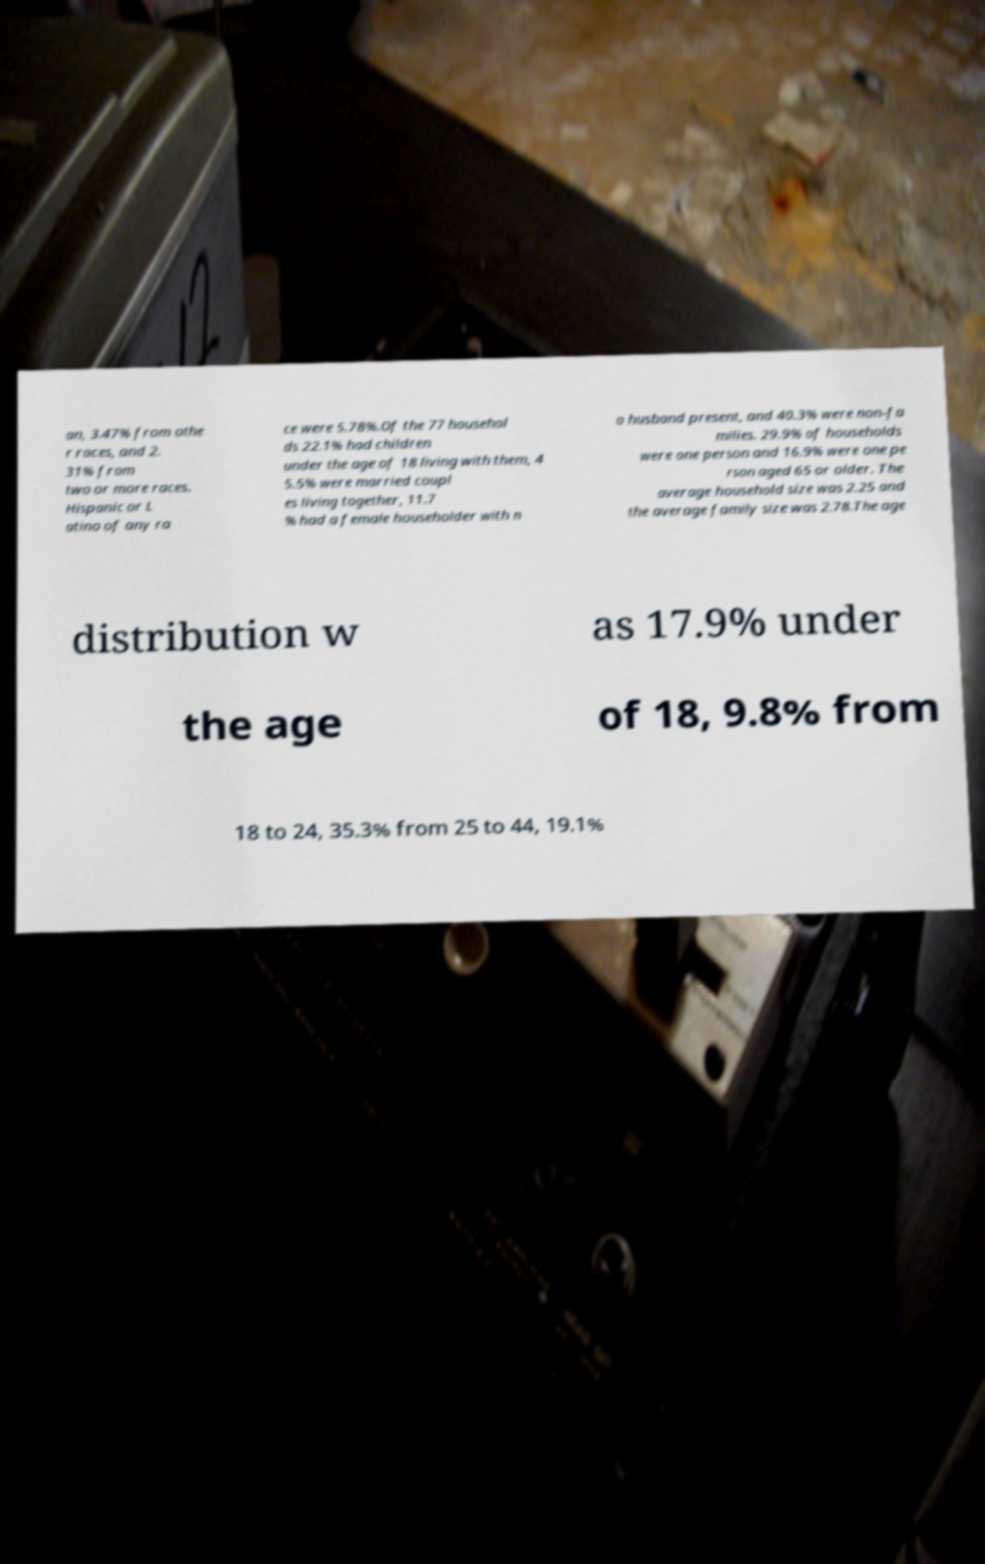Please identify and transcribe the text found in this image. an, 3.47% from othe r races, and 2. 31% from two or more races. Hispanic or L atino of any ra ce were 5.78%.Of the 77 househol ds 22.1% had children under the age of 18 living with them, 4 5.5% were married coupl es living together, 11.7 % had a female householder with n o husband present, and 40.3% were non-fa milies. 29.9% of households were one person and 16.9% were one pe rson aged 65 or older. The average household size was 2.25 and the average family size was 2.78.The age distribution w as 17.9% under the age of 18, 9.8% from 18 to 24, 35.3% from 25 to 44, 19.1% 